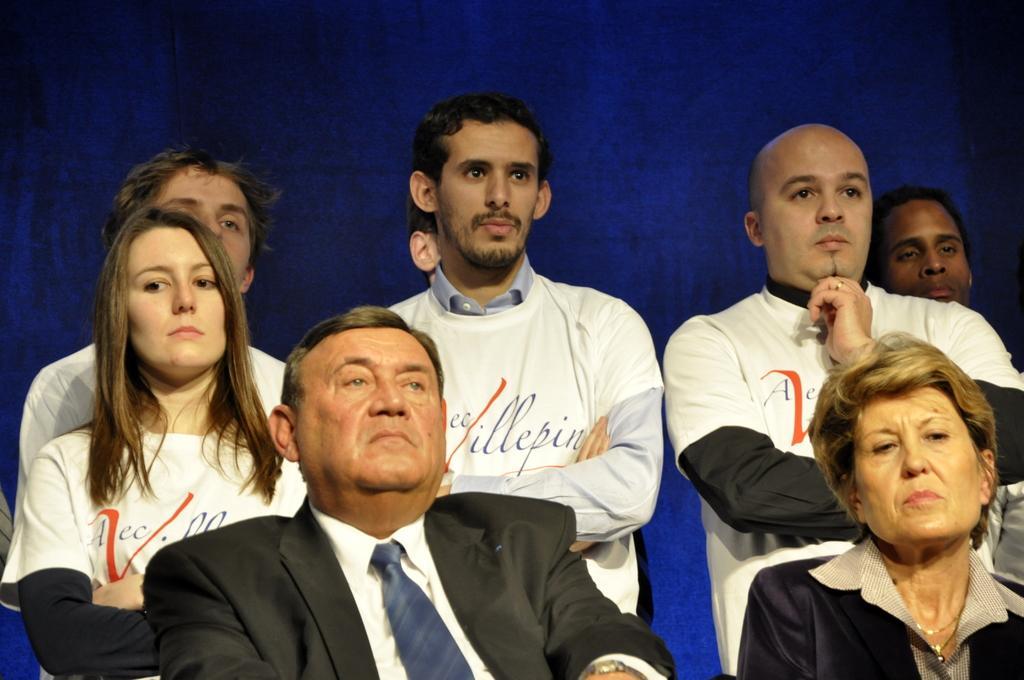Describe this image in one or two sentences. In the picture there are few people, among them the first two people were sitting and the remaining were standing in front of a blue background. 